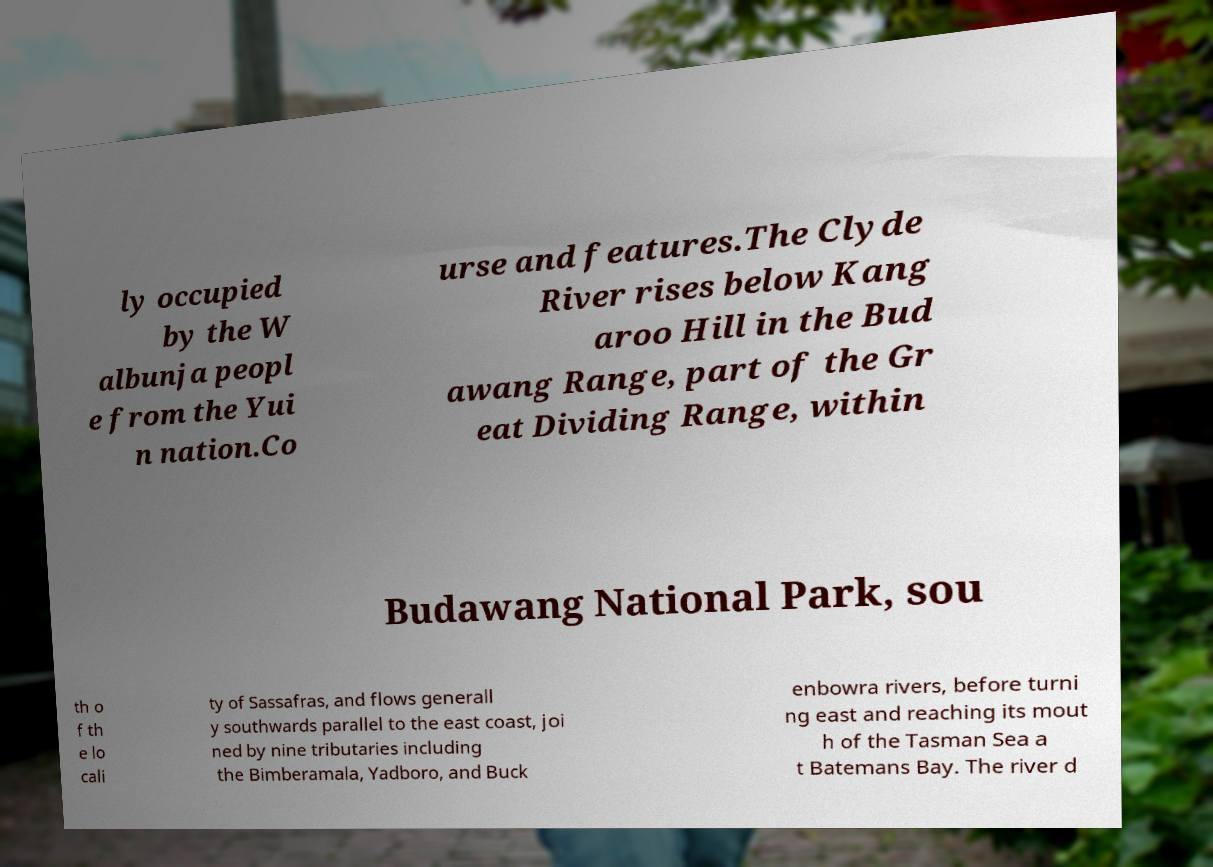Can you accurately transcribe the text from the provided image for me? ly occupied by the W albunja peopl e from the Yui n nation.Co urse and features.The Clyde River rises below Kang aroo Hill in the Bud awang Range, part of the Gr eat Dividing Range, within Budawang National Park, sou th o f th e lo cali ty of Sassafras, and flows generall y southwards parallel to the east coast, joi ned by nine tributaries including the Bimberamala, Yadboro, and Buck enbowra rivers, before turni ng east and reaching its mout h of the Tasman Sea a t Batemans Bay. The river d 